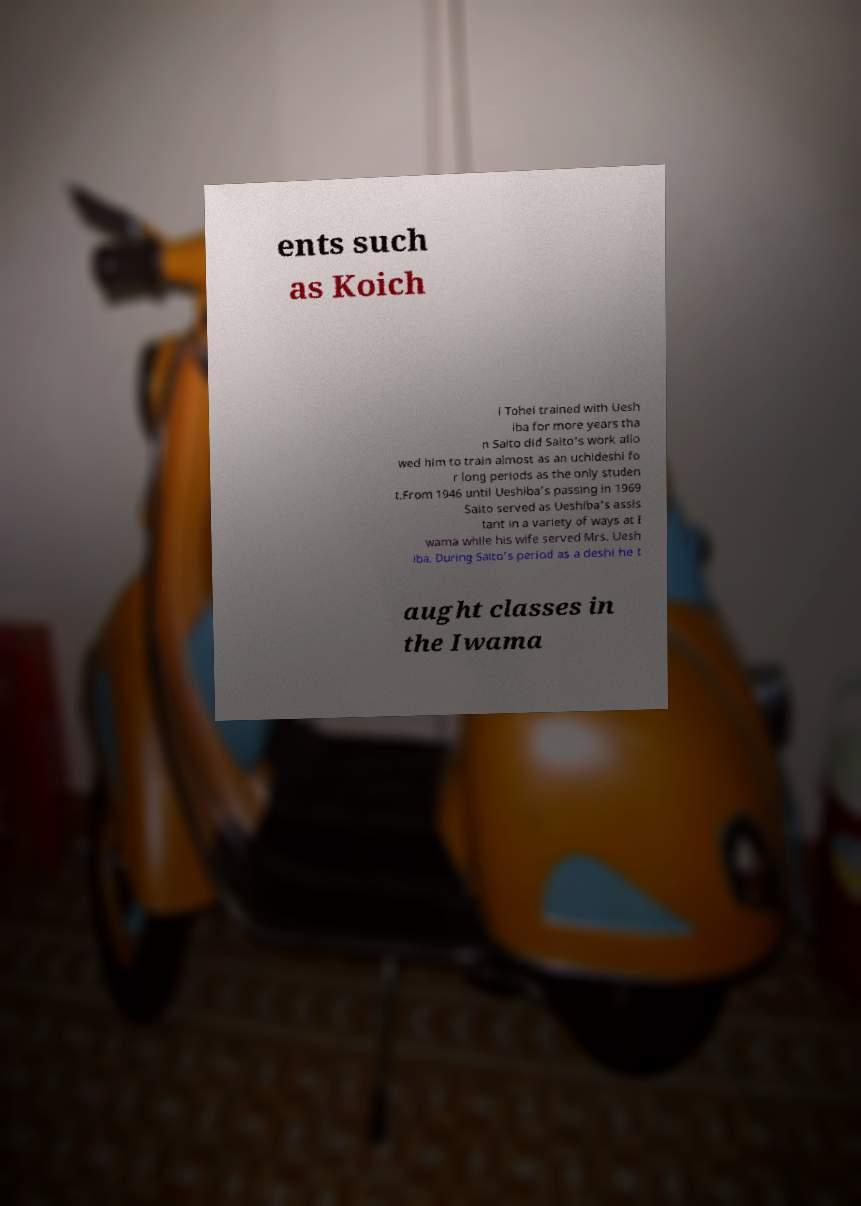Could you assist in decoding the text presented in this image and type it out clearly? ents such as Koich i Tohei trained with Uesh iba for more years tha n Saito did Saito's work allo wed him to train almost as an uchideshi fo r long periods as the only studen t.From 1946 until Ueshiba’s passing in 1969 Saito served as Ueshiba's assis tant in a variety of ways at I wama while his wife served Mrs. Uesh iba. During Saito’s period as a deshi he t aught classes in the Iwama 